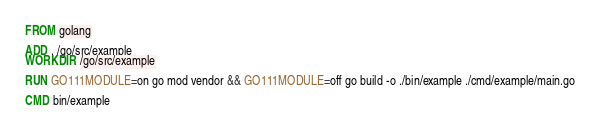<code> <loc_0><loc_0><loc_500><loc_500><_Dockerfile_>FROM golang

ADD . /go/src/example
WORKDIR /go/src/example

RUN GO111MODULE=on go mod vendor && GO111MODULE=off go build -o ./bin/example ./cmd/example/main.go

CMD bin/example</code> 